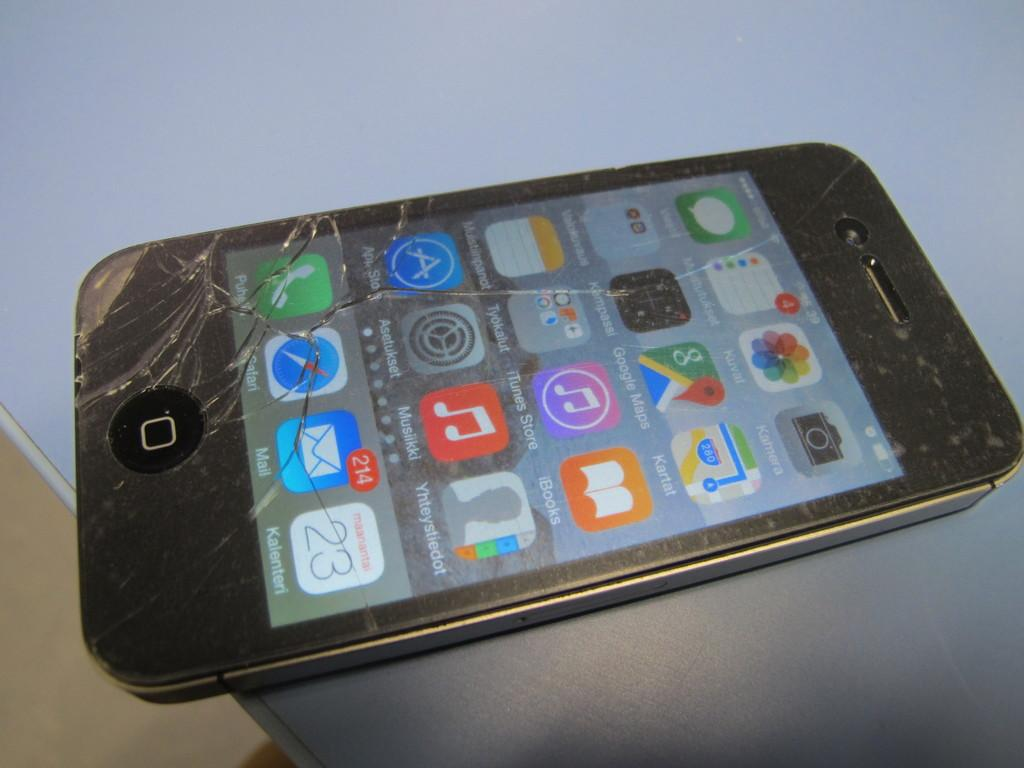<image>
Describe the image concisely. A black cellphone with the Mail app displaying 214 messages unread 